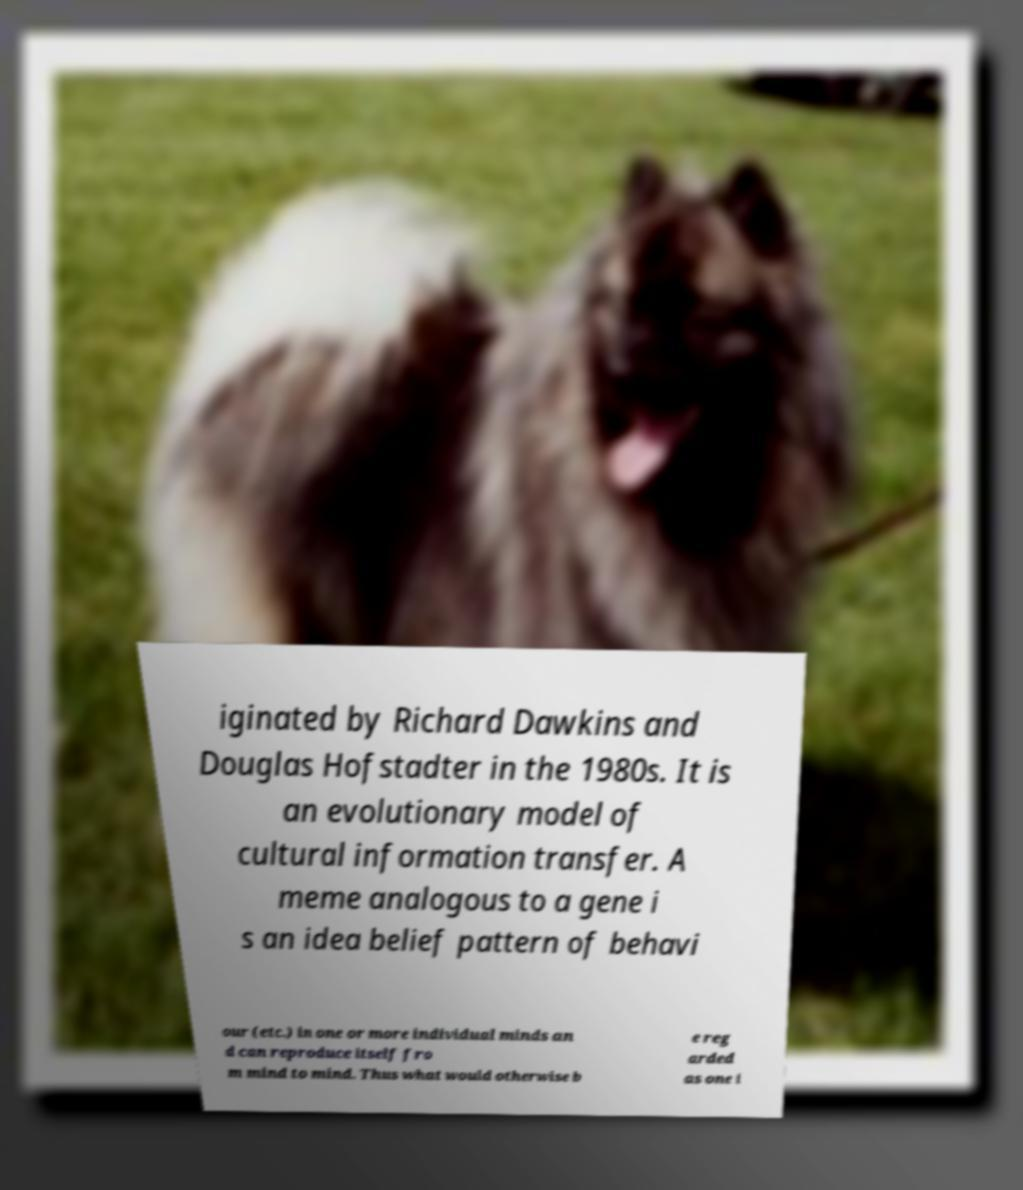Please read and relay the text visible in this image. What does it say? iginated by Richard Dawkins and Douglas Hofstadter in the 1980s. It is an evolutionary model of cultural information transfer. A meme analogous to a gene i s an idea belief pattern of behavi our (etc.) in one or more individual minds an d can reproduce itself fro m mind to mind. Thus what would otherwise b e reg arded as one i 